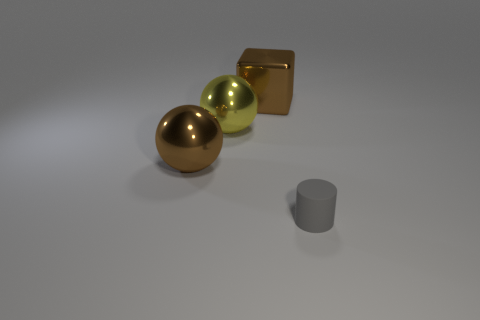What shape is the object that is both behind the gray cylinder and to the right of the yellow object? The object that is situated behind the gray cylinder and to the right of the yellow object is a cube. It appears to have a golden hue, which distinguishes it clearly against the other objects in the scene. 